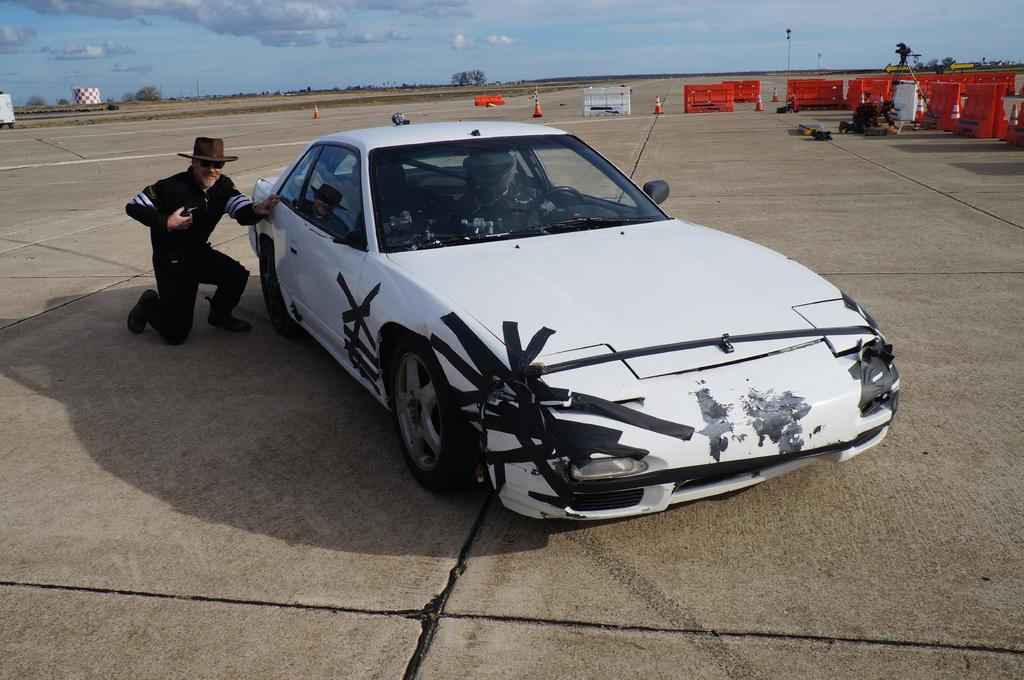What is located in the foreground of the image? There is a car, a man, and barricades in the foreground of the image. Can you describe the man in the image? The man is in the foreground of the image. What else can be seen in the foreground of the image besides the car, man, and barricades? There are other objects in the foreground of the image. What is visible in the background of the image? Trees, poles, and the sky are visible in the background of the image. Can you tell me how many monkeys are sitting on the yoke in the image? There are no monkeys or yokes present in the image. What type of low object is visible in the image? There is no low object mentioned in the provided facts, so it cannot be determined from the image. 